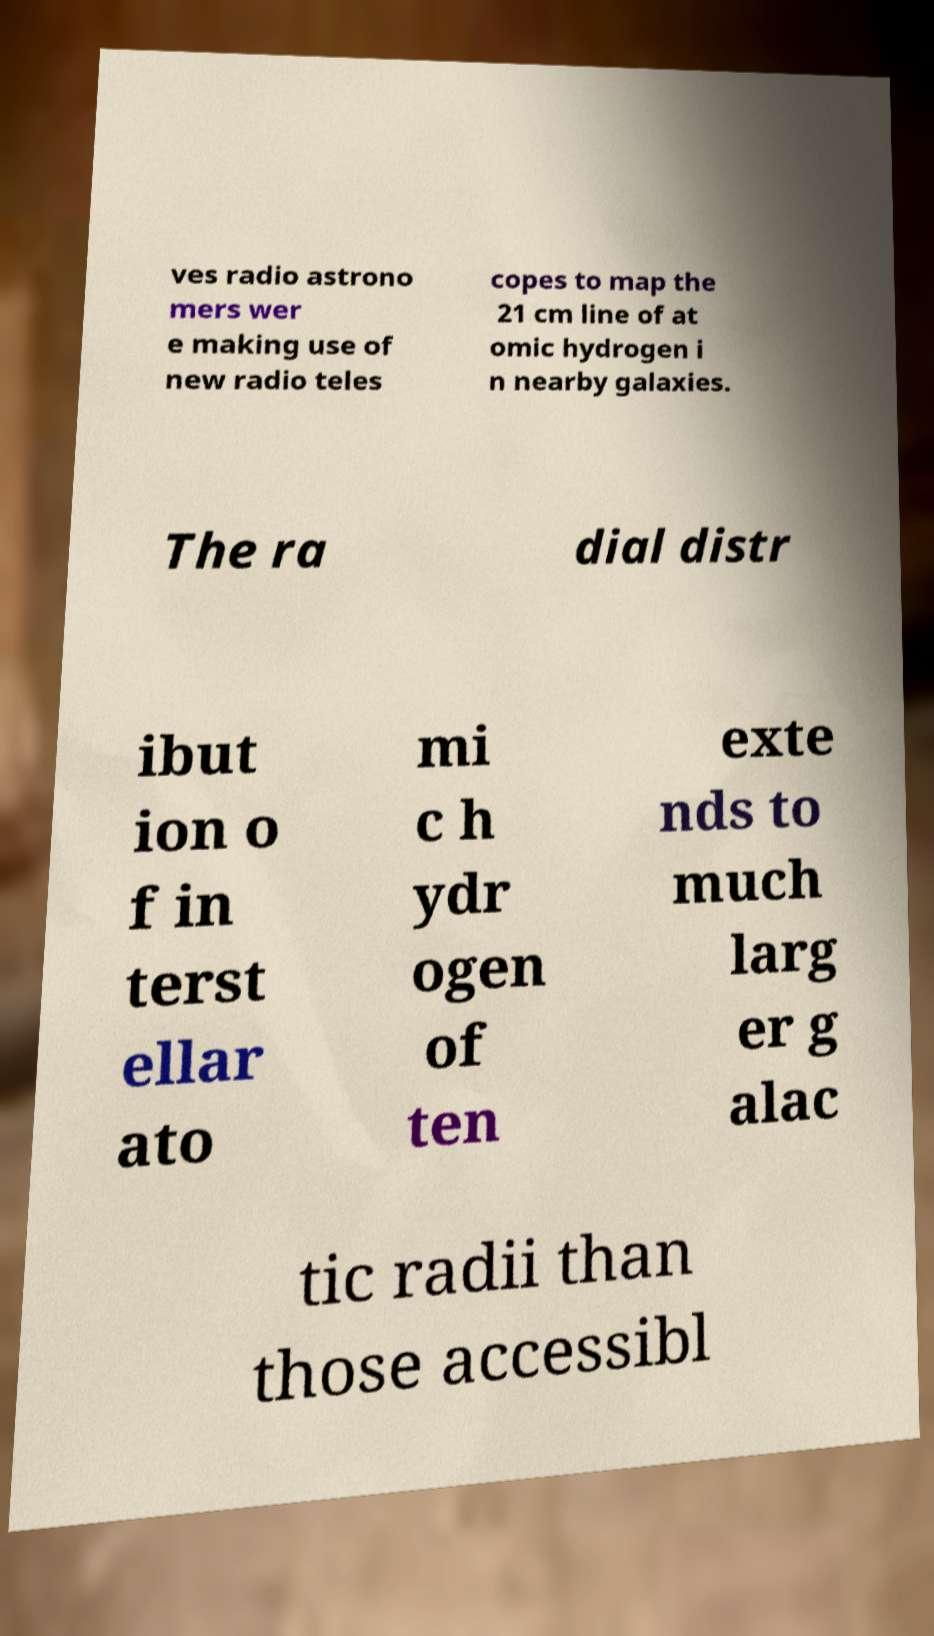Can you read and provide the text displayed in the image?This photo seems to have some interesting text. Can you extract and type it out for me? ves radio astrono mers wer e making use of new radio teles copes to map the 21 cm line of at omic hydrogen i n nearby galaxies. The ra dial distr ibut ion o f in terst ellar ato mi c h ydr ogen of ten exte nds to much larg er g alac tic radii than those accessibl 